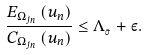Convert formula to latex. <formula><loc_0><loc_0><loc_500><loc_500>\frac { E _ { \Omega _ { j _ { n } } } \left ( u _ { n } \right ) } { C _ { \Omega _ { j _ { n } } } \left ( u _ { n } \right ) } \leq \Lambda _ { _ { \bar { \sigma } } } + \varepsilon .</formula> 